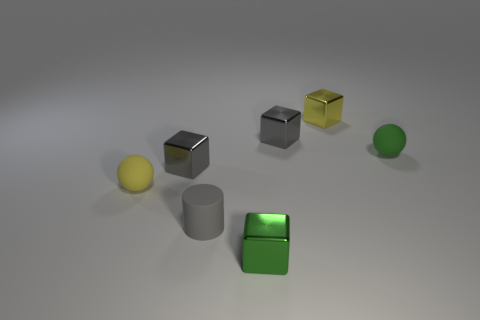Are there any other things that are the same shape as the gray rubber thing?
Keep it short and to the point. No. What color is the sphere that is left of the small green matte thing?
Offer a very short reply. Yellow. Is the shape of the yellow object that is in front of the tiny green matte object the same as  the tiny green matte thing?
Keep it short and to the point. Yes. What is the material of the other thing that is the same shape as the yellow rubber thing?
Your answer should be very brief. Rubber. How many things are shiny blocks on the left side of the small green shiny block or gray cubes to the left of the rubber cylinder?
Offer a terse response. 1. Does the rubber cylinder have the same color as the sphere on the left side of the green matte sphere?
Offer a terse response. No. What is the shape of the green thing that is made of the same material as the cylinder?
Offer a terse response. Sphere. What number of shiny cubes are there?
Your answer should be very brief. 4. How many things are matte spheres that are right of the yellow matte sphere or small yellow blocks?
Your answer should be very brief. 2. There is a tiny metal cube on the left side of the green block; does it have the same color as the matte cylinder?
Keep it short and to the point. Yes. 